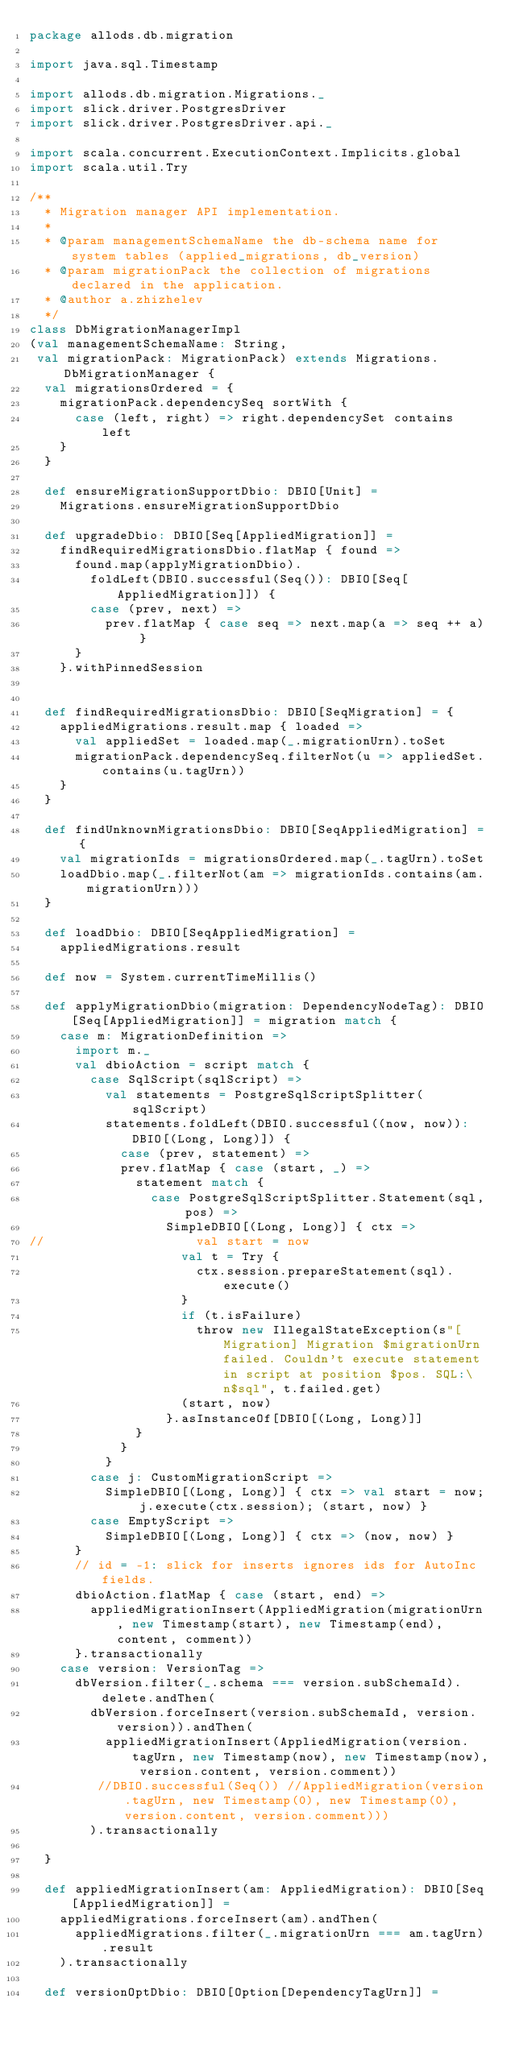<code> <loc_0><loc_0><loc_500><loc_500><_Scala_>package allods.db.migration

import java.sql.Timestamp

import allods.db.migration.Migrations._
import slick.driver.PostgresDriver
import slick.driver.PostgresDriver.api._

import scala.concurrent.ExecutionContext.Implicits.global
import scala.util.Try

/**
  * Migration manager API implementation.
  *
  * @param managementSchemaName the db-schema name for system tables (applied_migrations, db_version)
  * @param migrationPack the collection of migrations declared in the application.
  * @author a.zhizhelev
  */
class DbMigrationManagerImpl
(val managementSchemaName: String,
 val migrationPack: MigrationPack) extends Migrations.DbMigrationManager {
  val migrationsOrdered = {
    migrationPack.dependencySeq sortWith {
      case (left, right) => right.dependencySet contains left
    }
  }

  def ensureMigrationSupportDbio: DBIO[Unit] =
    Migrations.ensureMigrationSupportDbio

  def upgradeDbio: DBIO[Seq[AppliedMigration]] =
    findRequiredMigrationsDbio.flatMap { found =>
      found.map(applyMigrationDbio).
        foldLeft(DBIO.successful(Seq()): DBIO[Seq[AppliedMigration]]) {
        case (prev, next) =>
          prev.flatMap { case seq => next.map(a => seq ++ a) }
      }
    }.withPinnedSession


  def findRequiredMigrationsDbio: DBIO[SeqMigration] = {
    appliedMigrations.result.map { loaded =>
      val appliedSet = loaded.map(_.migrationUrn).toSet
      migrationPack.dependencySeq.filterNot(u => appliedSet.contains(u.tagUrn))
    }
  }

  def findUnknownMigrationsDbio: DBIO[SeqAppliedMigration] = {
    val migrationIds = migrationsOrdered.map(_.tagUrn).toSet
    loadDbio.map(_.filterNot(am => migrationIds.contains(am.migrationUrn)))
  }

  def loadDbio: DBIO[SeqAppliedMigration] =
    appliedMigrations.result

  def now = System.currentTimeMillis()

  def applyMigrationDbio(migration: DependencyNodeTag): DBIO[Seq[AppliedMigration]] = migration match {
    case m: MigrationDefinition =>
      import m._
      val dbioAction = script match {
        case SqlScript(sqlScript) =>
          val statements = PostgreSqlScriptSplitter(sqlScript)
          statements.foldLeft(DBIO.successful((now, now)): DBIO[(Long, Long)]) {
            case (prev, statement) =>
            prev.flatMap { case (start, _) =>
              statement match {
                case PostgreSqlScriptSplitter.Statement(sql, pos) =>
                  SimpleDBIO[(Long, Long)] { ctx =>
//                    val start = now
                    val t = Try {
                      ctx.session.prepareStatement(sql).execute()
                    }
                    if (t.isFailure)
                      throw new IllegalStateException(s"[Migration] Migration $migrationUrn failed. Couldn't execute statement in script at position $pos. SQL:\n$sql", t.failed.get)
                    (start, now)
                  }.asInstanceOf[DBIO[(Long, Long)]]
              }
            }
          }
        case j: CustomMigrationScript =>
          SimpleDBIO[(Long, Long)] { ctx => val start = now; j.execute(ctx.session); (start, now) }
        case EmptyScript =>
          SimpleDBIO[(Long, Long)] { ctx => (now, now) }
      }
      // id = -1: slick for inserts ignores ids for AutoInc fields.
      dbioAction.flatMap { case (start, end) =>
        appliedMigrationInsert(AppliedMigration(migrationUrn, new Timestamp(start), new Timestamp(end), content, comment))
      }.transactionally
    case version: VersionTag =>
      dbVersion.filter(_.schema === version.subSchemaId).delete.andThen(
        dbVersion.forceInsert(version.subSchemaId, version.version)).andThen(
          appliedMigrationInsert(AppliedMigration(version.tagUrn, new Timestamp(now), new Timestamp(now), version.content, version.comment))
         //DBIO.successful(Seq()) //AppliedMigration(version.tagUrn, new Timestamp(0), new Timestamp(0), version.content, version.comment)))
        ).transactionally

  }

  def appliedMigrationInsert(am: AppliedMigration): DBIO[Seq[AppliedMigration]] =
    appliedMigrations.forceInsert(am).andThen(
      appliedMigrations.filter(_.migrationUrn === am.tagUrn).result
    ).transactionally

  def versionOptDbio: DBIO[Option[DependencyTagUrn]] =</code> 